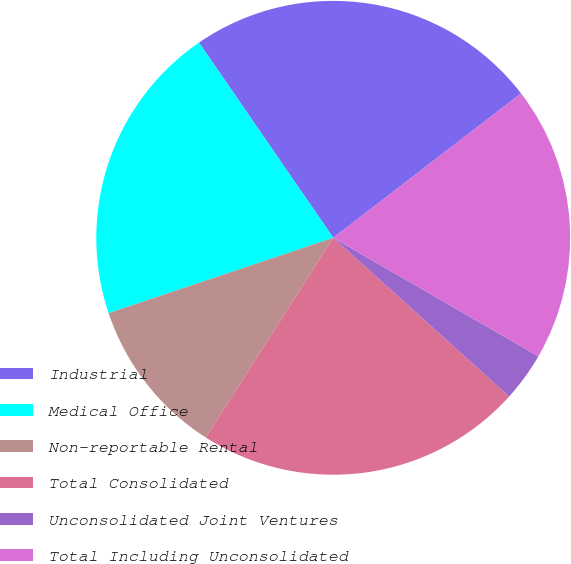Convert chart. <chart><loc_0><loc_0><loc_500><loc_500><pie_chart><fcel>Industrial<fcel>Medical Office<fcel>Non-reportable Rental<fcel>Total Consolidated<fcel>Unconsolidated Joint Ventures<fcel>Total Including Unconsolidated<nl><fcel>24.16%<fcel>20.56%<fcel>10.81%<fcel>22.36%<fcel>3.34%<fcel>18.77%<nl></chart> 